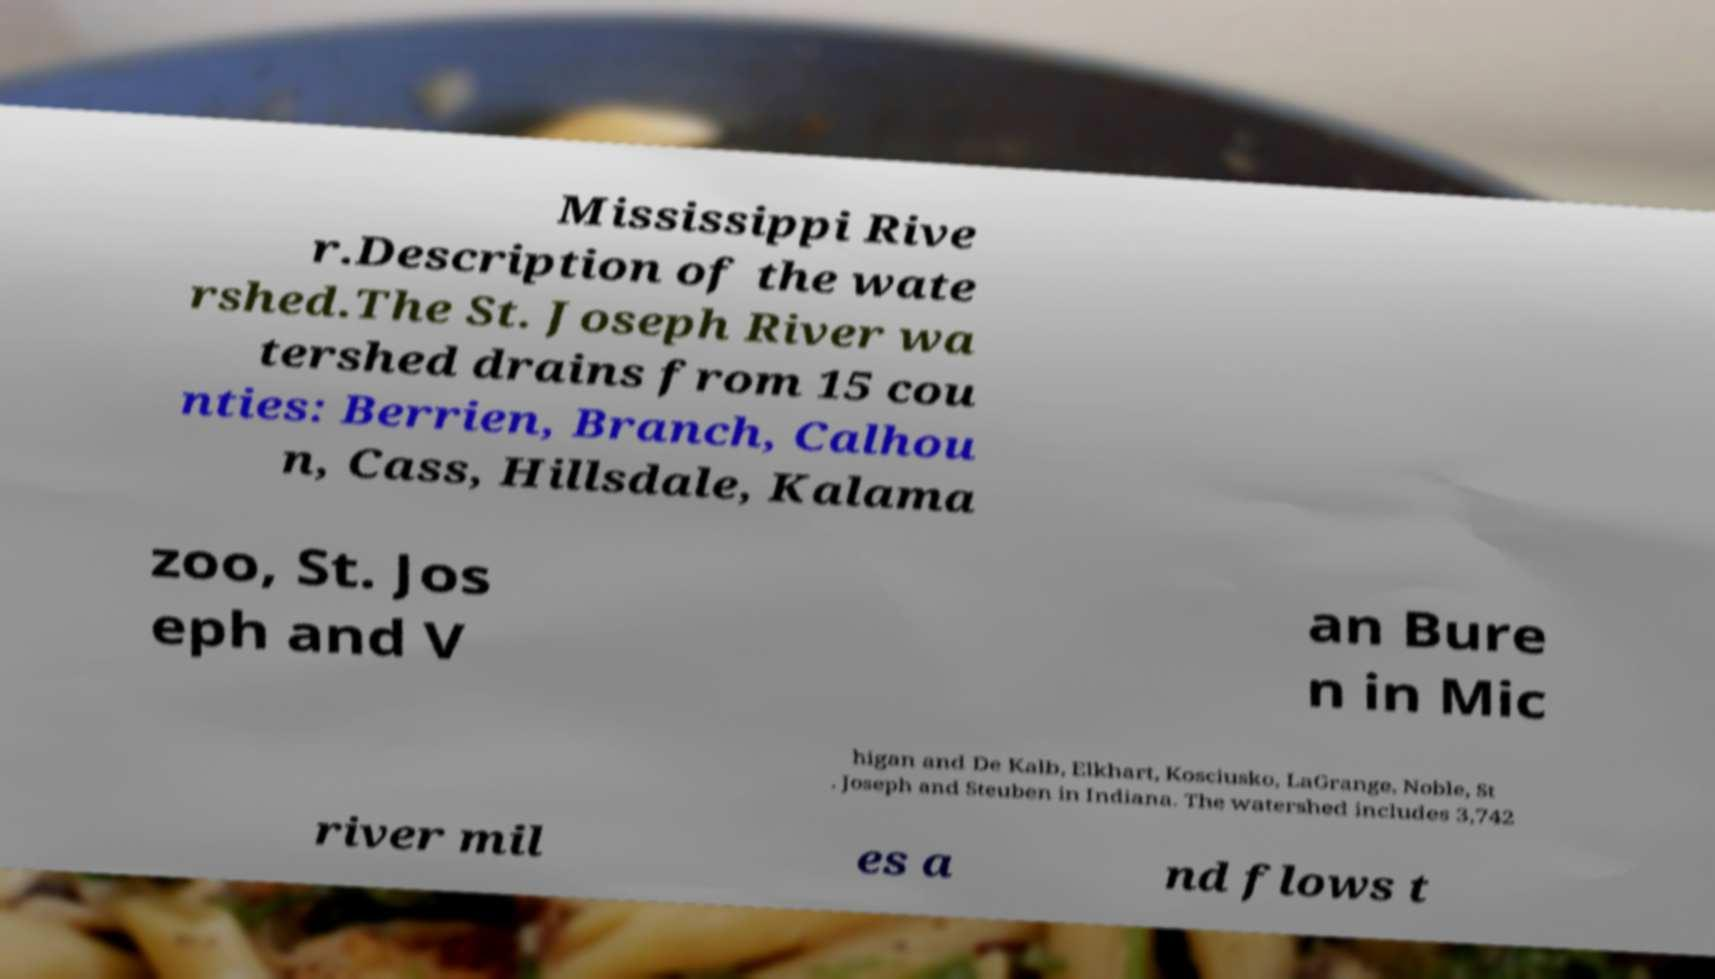Can you accurately transcribe the text from the provided image for me? Mississippi Rive r.Description of the wate rshed.The St. Joseph River wa tershed drains from 15 cou nties: Berrien, Branch, Calhou n, Cass, Hillsdale, Kalama zoo, St. Jos eph and V an Bure n in Mic higan and De Kalb, Elkhart, Kosciusko, LaGrange, Noble, St . Joseph and Steuben in Indiana. The watershed includes 3,742 river mil es a nd flows t 